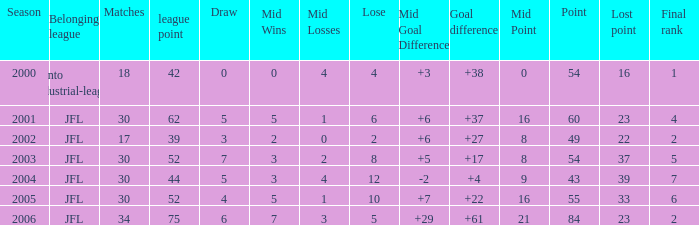Parse the full table. {'header': ['Season', 'Belonging league', 'Matches', 'league point', 'Draw', 'Mid Wins', 'Mid Losses', 'Lose', 'Mid Goal Difference', 'Goal difference', 'Mid Point', 'Point', 'Lost point', 'Final rank'], 'rows': [['2000', 'Kanto industrial-league', '18', '42', '0', '0', '4', '4', '+3', '+38', '0', '54', '16', '1'], ['2001', 'JFL', '30', '62', '5', '5', '1', '6', '+6', '+37', '16', '60', '23', '4'], ['2002', 'JFL', '17', '39', '3', '2', '0', '2', '+6', '+27', '8', '49', '22', '2'], ['2003', 'JFL', '30', '52', '7', '3', '2', '8', '+5', '+17', '8', '54', '37', '5'], ['2004', 'JFL', '30', '44', '5', '3', '4', '12', '-2', '+4', '9', '43', '39', '7'], ['2005', 'JFL', '30', '52', '4', '5', '1', '10', '+7', '+22', '16', '55', '33', '6'], ['2006', 'JFL', '34', '75', '6', '7', '3', '5', '+29', '+61', '21', '84', '23', '2']]} I want the average lose for lost point more than 16 and goal difference less than 37 and point less than 43 None. 